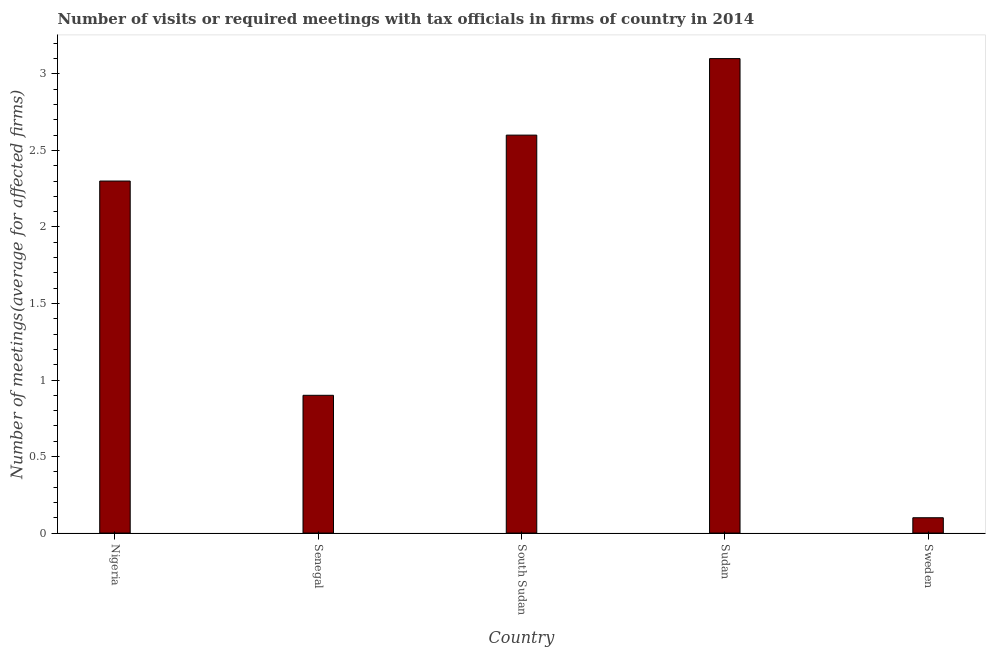Does the graph contain any zero values?
Give a very brief answer. No. What is the title of the graph?
Your answer should be compact. Number of visits or required meetings with tax officials in firms of country in 2014. What is the label or title of the Y-axis?
Keep it short and to the point. Number of meetings(average for affected firms). Across all countries, what is the maximum number of required meetings with tax officials?
Provide a short and direct response. 3.1. Across all countries, what is the minimum number of required meetings with tax officials?
Provide a succinct answer. 0.1. In which country was the number of required meetings with tax officials maximum?
Provide a succinct answer. Sudan. What is the average number of required meetings with tax officials per country?
Give a very brief answer. 1.8. In how many countries, is the number of required meetings with tax officials greater than 2.3 ?
Your response must be concise. 2. Is the number of required meetings with tax officials in Nigeria less than that in Sudan?
Your response must be concise. Yes. Is the difference between the number of required meetings with tax officials in Nigeria and South Sudan greater than the difference between any two countries?
Make the answer very short. No. What is the difference between the highest and the second highest number of required meetings with tax officials?
Your answer should be very brief. 0.5. Are all the bars in the graph horizontal?
Give a very brief answer. No. What is the difference between two consecutive major ticks on the Y-axis?
Offer a terse response. 0.5. Are the values on the major ticks of Y-axis written in scientific E-notation?
Provide a short and direct response. No. What is the Number of meetings(average for affected firms) of Nigeria?
Give a very brief answer. 2.3. What is the Number of meetings(average for affected firms) in South Sudan?
Give a very brief answer. 2.6. What is the difference between the Number of meetings(average for affected firms) in Nigeria and Sweden?
Provide a short and direct response. 2.2. What is the difference between the Number of meetings(average for affected firms) in Senegal and South Sudan?
Make the answer very short. -1.7. What is the difference between the Number of meetings(average for affected firms) in Senegal and Sweden?
Provide a short and direct response. 0.8. What is the difference between the Number of meetings(average for affected firms) in South Sudan and Sudan?
Your response must be concise. -0.5. What is the difference between the Number of meetings(average for affected firms) in South Sudan and Sweden?
Your answer should be very brief. 2.5. What is the ratio of the Number of meetings(average for affected firms) in Nigeria to that in Senegal?
Make the answer very short. 2.56. What is the ratio of the Number of meetings(average for affected firms) in Nigeria to that in South Sudan?
Give a very brief answer. 0.89. What is the ratio of the Number of meetings(average for affected firms) in Nigeria to that in Sudan?
Make the answer very short. 0.74. What is the ratio of the Number of meetings(average for affected firms) in Nigeria to that in Sweden?
Offer a terse response. 23. What is the ratio of the Number of meetings(average for affected firms) in Senegal to that in South Sudan?
Ensure brevity in your answer.  0.35. What is the ratio of the Number of meetings(average for affected firms) in Senegal to that in Sudan?
Provide a short and direct response. 0.29. What is the ratio of the Number of meetings(average for affected firms) in Senegal to that in Sweden?
Your answer should be compact. 9. What is the ratio of the Number of meetings(average for affected firms) in South Sudan to that in Sudan?
Your response must be concise. 0.84. What is the ratio of the Number of meetings(average for affected firms) in South Sudan to that in Sweden?
Provide a short and direct response. 26. What is the ratio of the Number of meetings(average for affected firms) in Sudan to that in Sweden?
Ensure brevity in your answer.  31. 